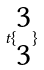<formula> <loc_0><loc_0><loc_500><loc_500>t \{ \begin{matrix} 3 \\ 3 \end{matrix} \}</formula> 